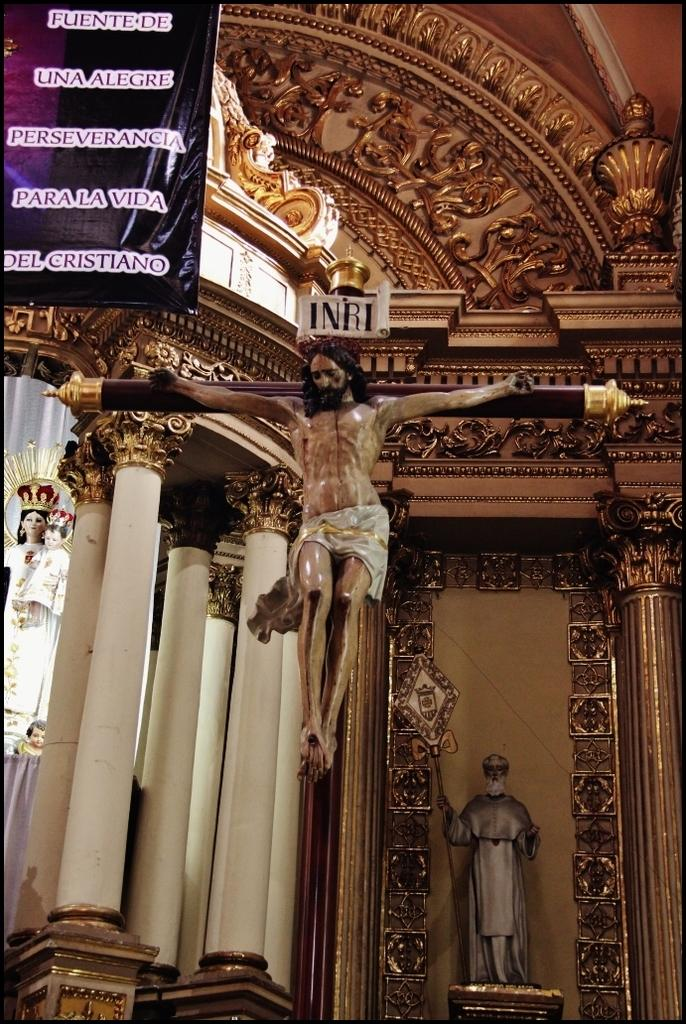What architectural elements can be seen in the image? There are pillars in the image. What type of structure are the pillars part of? The pillars are part of a cathedral construction. What is located on the top left side of the image? There is a banner on the top left side of the image. What type of figures are present in the image? There are statues of goddesses in the image. Can you tell me what type of picture is hanging on the seashore in the image? There is no picture hanging on the seashore in the image, nor is there any mention of a seashore in the provided facts. 